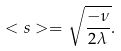Convert formula to latex. <formula><loc_0><loc_0><loc_500><loc_500>< s > = \sqrt { \frac { - \nu } { 2 \lambda } } .</formula> 